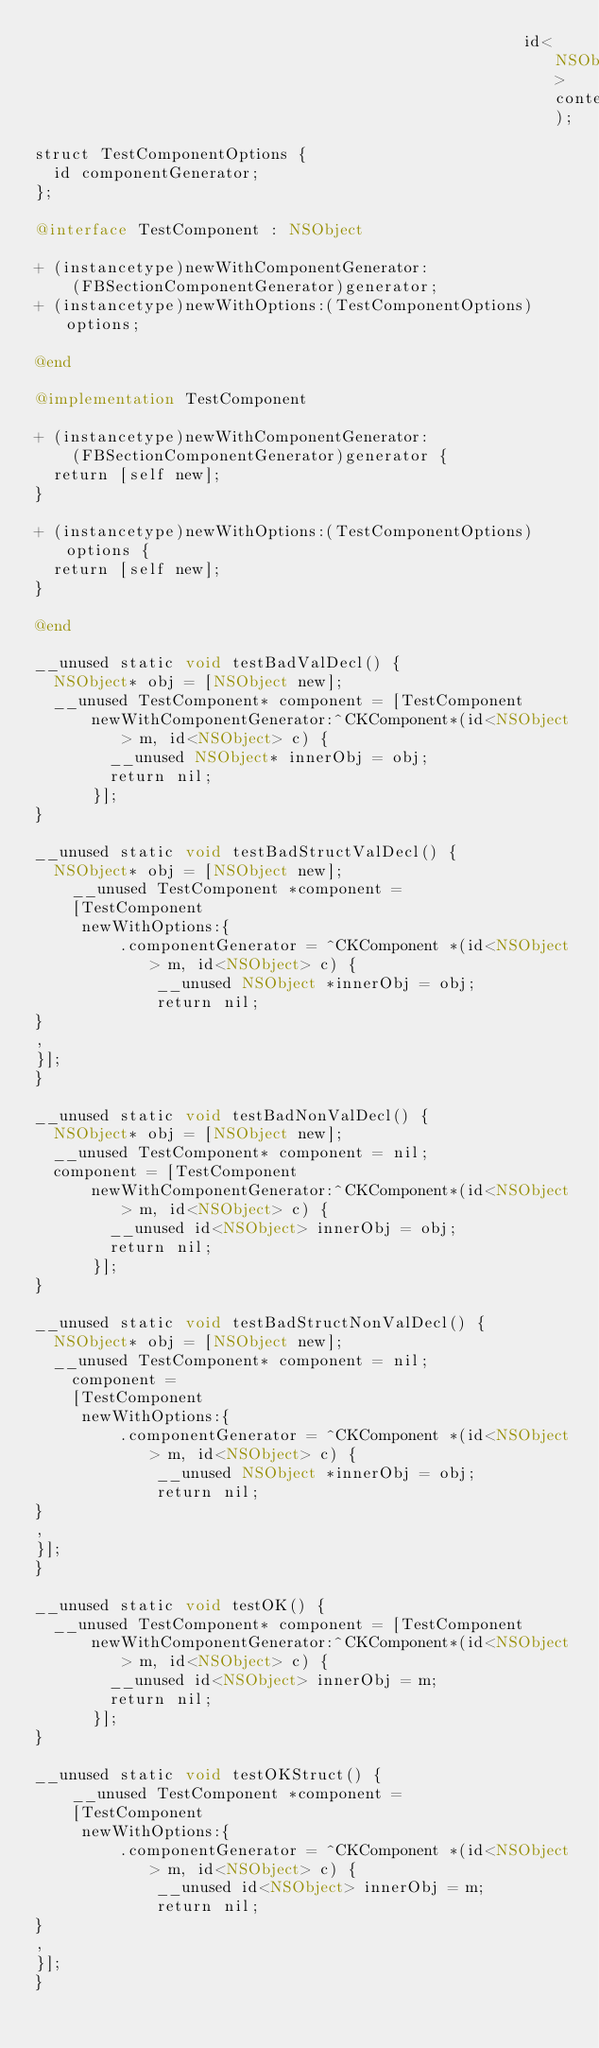Convert code to text. <code><loc_0><loc_0><loc_500><loc_500><_ObjectiveC_>                                                    id<NSObject> context);

struct TestComponentOptions {
  id componentGenerator;
};

@interface TestComponent : NSObject

+ (instancetype)newWithComponentGenerator:
    (FBSectionComponentGenerator)generator;
+ (instancetype)newWithOptions:(TestComponentOptions)options;

@end

@implementation TestComponent

+ (instancetype)newWithComponentGenerator:
    (FBSectionComponentGenerator)generator {
  return [self new];
}

+ (instancetype)newWithOptions:(TestComponentOptions)options {
  return [self new];
}

@end

__unused static void testBadValDecl() {
  NSObject* obj = [NSObject new];
  __unused TestComponent* component = [TestComponent
      newWithComponentGenerator:^CKComponent*(id<NSObject> m, id<NSObject> c) {
        __unused NSObject* innerObj = obj;
        return nil;
      }];
}

__unused static void testBadStructValDecl() {
  NSObject* obj = [NSObject new];
    __unused TestComponent *component =
    [TestComponent
     newWithOptions:{
         .componentGenerator = ^CKComponent *(id<NSObject> m, id<NSObject> c) {
             __unused NSObject *innerObj = obj;
             return nil;
}
,
}];
}

__unused static void testBadNonValDecl() {
  NSObject* obj = [NSObject new];
  __unused TestComponent* component = nil;
  component = [TestComponent
      newWithComponentGenerator:^CKComponent*(id<NSObject> m, id<NSObject> c) {
        __unused id<NSObject> innerObj = obj;
        return nil;
      }];
}

__unused static void testBadStructNonValDecl() {
  NSObject* obj = [NSObject new];
  __unused TestComponent* component = nil;
    component =
    [TestComponent
     newWithOptions:{
         .componentGenerator = ^CKComponent *(id<NSObject> m, id<NSObject> c) {
             __unused NSObject *innerObj = obj;
             return nil;
}
,
}];
}

__unused static void testOK() {
  __unused TestComponent* component = [TestComponent
      newWithComponentGenerator:^CKComponent*(id<NSObject> m, id<NSObject> c) {
        __unused id<NSObject> innerObj = m;
        return nil;
      }];
}

__unused static void testOKStruct() {
    __unused TestComponent *component =
    [TestComponent
     newWithOptions:{
         .componentGenerator = ^CKComponent *(id<NSObject> m, id<NSObject> c) {
             __unused id<NSObject> innerObj = m;
             return nil;
}
,
}];
}
</code> 